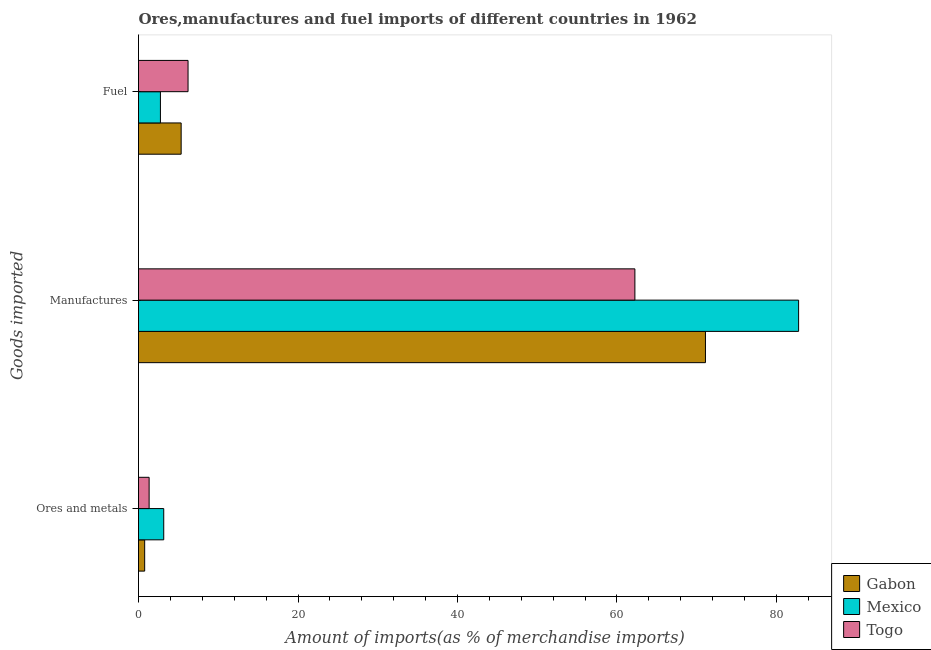How many different coloured bars are there?
Keep it short and to the point. 3. Are the number of bars per tick equal to the number of legend labels?
Your answer should be very brief. Yes. Are the number of bars on each tick of the Y-axis equal?
Keep it short and to the point. Yes. How many bars are there on the 2nd tick from the top?
Offer a very short reply. 3. How many bars are there on the 3rd tick from the bottom?
Give a very brief answer. 3. What is the label of the 2nd group of bars from the top?
Keep it short and to the point. Manufactures. What is the percentage of fuel imports in Mexico?
Your response must be concise. 2.75. Across all countries, what is the maximum percentage of manufactures imports?
Offer a terse response. 82.78. Across all countries, what is the minimum percentage of fuel imports?
Provide a succinct answer. 2.75. In which country was the percentage of ores and metals imports maximum?
Provide a short and direct response. Mexico. In which country was the percentage of ores and metals imports minimum?
Keep it short and to the point. Gabon. What is the total percentage of ores and metals imports in the graph?
Your response must be concise. 5.27. What is the difference between the percentage of fuel imports in Togo and that in Mexico?
Ensure brevity in your answer.  3.47. What is the difference between the percentage of ores and metals imports in Mexico and the percentage of manufactures imports in Togo?
Keep it short and to the point. -59.08. What is the average percentage of ores and metals imports per country?
Give a very brief answer. 1.76. What is the difference between the percentage of fuel imports and percentage of ores and metals imports in Togo?
Offer a terse response. 4.88. In how many countries, is the percentage of manufactures imports greater than 44 %?
Your response must be concise. 3. What is the ratio of the percentage of manufactures imports in Gabon to that in Mexico?
Provide a short and direct response. 0.86. Is the percentage of manufactures imports in Togo less than that in Gabon?
Keep it short and to the point. Yes. What is the difference between the highest and the second highest percentage of manufactures imports?
Your answer should be compact. 11.68. What is the difference between the highest and the lowest percentage of fuel imports?
Offer a very short reply. 3.47. What does the 1st bar from the top in Manufactures represents?
Keep it short and to the point. Togo. What does the 1st bar from the bottom in Manufactures represents?
Provide a succinct answer. Gabon. What is the difference between two consecutive major ticks on the X-axis?
Make the answer very short. 20. Does the graph contain any zero values?
Your answer should be very brief. No. Does the graph contain grids?
Provide a short and direct response. No. Where does the legend appear in the graph?
Provide a short and direct response. Bottom right. How are the legend labels stacked?
Ensure brevity in your answer.  Vertical. What is the title of the graph?
Keep it short and to the point. Ores,manufactures and fuel imports of different countries in 1962. What is the label or title of the X-axis?
Your response must be concise. Amount of imports(as % of merchandise imports). What is the label or title of the Y-axis?
Offer a very short reply. Goods imported. What is the Amount of imports(as % of merchandise imports) of Gabon in Ores and metals?
Offer a very short reply. 0.77. What is the Amount of imports(as % of merchandise imports) in Mexico in Ores and metals?
Your answer should be very brief. 3.16. What is the Amount of imports(as % of merchandise imports) in Togo in Ores and metals?
Your answer should be compact. 1.33. What is the Amount of imports(as % of merchandise imports) in Gabon in Manufactures?
Ensure brevity in your answer.  71.1. What is the Amount of imports(as % of merchandise imports) in Mexico in Manufactures?
Provide a short and direct response. 82.78. What is the Amount of imports(as % of merchandise imports) of Togo in Manufactures?
Keep it short and to the point. 62.25. What is the Amount of imports(as % of merchandise imports) of Gabon in Fuel?
Provide a short and direct response. 5.35. What is the Amount of imports(as % of merchandise imports) of Mexico in Fuel?
Provide a succinct answer. 2.75. What is the Amount of imports(as % of merchandise imports) of Togo in Fuel?
Give a very brief answer. 6.21. Across all Goods imported, what is the maximum Amount of imports(as % of merchandise imports) in Gabon?
Keep it short and to the point. 71.1. Across all Goods imported, what is the maximum Amount of imports(as % of merchandise imports) of Mexico?
Keep it short and to the point. 82.78. Across all Goods imported, what is the maximum Amount of imports(as % of merchandise imports) in Togo?
Your answer should be compact. 62.25. Across all Goods imported, what is the minimum Amount of imports(as % of merchandise imports) in Gabon?
Make the answer very short. 0.77. Across all Goods imported, what is the minimum Amount of imports(as % of merchandise imports) of Mexico?
Offer a terse response. 2.75. Across all Goods imported, what is the minimum Amount of imports(as % of merchandise imports) of Togo?
Your answer should be very brief. 1.33. What is the total Amount of imports(as % of merchandise imports) in Gabon in the graph?
Offer a very short reply. 77.22. What is the total Amount of imports(as % of merchandise imports) in Mexico in the graph?
Ensure brevity in your answer.  88.69. What is the total Amount of imports(as % of merchandise imports) of Togo in the graph?
Keep it short and to the point. 69.79. What is the difference between the Amount of imports(as % of merchandise imports) in Gabon in Ores and metals and that in Manufactures?
Provide a succinct answer. -70.32. What is the difference between the Amount of imports(as % of merchandise imports) of Mexico in Ores and metals and that in Manufactures?
Provide a short and direct response. -79.61. What is the difference between the Amount of imports(as % of merchandise imports) of Togo in Ores and metals and that in Manufactures?
Your answer should be compact. -60.92. What is the difference between the Amount of imports(as % of merchandise imports) of Gabon in Ores and metals and that in Fuel?
Give a very brief answer. -4.58. What is the difference between the Amount of imports(as % of merchandise imports) of Mexico in Ores and metals and that in Fuel?
Keep it short and to the point. 0.42. What is the difference between the Amount of imports(as % of merchandise imports) in Togo in Ores and metals and that in Fuel?
Ensure brevity in your answer.  -4.88. What is the difference between the Amount of imports(as % of merchandise imports) in Gabon in Manufactures and that in Fuel?
Offer a very short reply. 65.75. What is the difference between the Amount of imports(as % of merchandise imports) in Mexico in Manufactures and that in Fuel?
Your answer should be compact. 80.03. What is the difference between the Amount of imports(as % of merchandise imports) in Togo in Manufactures and that in Fuel?
Your response must be concise. 56.03. What is the difference between the Amount of imports(as % of merchandise imports) in Gabon in Ores and metals and the Amount of imports(as % of merchandise imports) in Mexico in Manufactures?
Your response must be concise. -82.01. What is the difference between the Amount of imports(as % of merchandise imports) in Gabon in Ores and metals and the Amount of imports(as % of merchandise imports) in Togo in Manufactures?
Provide a short and direct response. -61.48. What is the difference between the Amount of imports(as % of merchandise imports) in Mexico in Ores and metals and the Amount of imports(as % of merchandise imports) in Togo in Manufactures?
Provide a short and direct response. -59.08. What is the difference between the Amount of imports(as % of merchandise imports) in Gabon in Ores and metals and the Amount of imports(as % of merchandise imports) in Mexico in Fuel?
Your answer should be compact. -1.97. What is the difference between the Amount of imports(as % of merchandise imports) of Gabon in Ores and metals and the Amount of imports(as % of merchandise imports) of Togo in Fuel?
Offer a terse response. -5.44. What is the difference between the Amount of imports(as % of merchandise imports) in Mexico in Ores and metals and the Amount of imports(as % of merchandise imports) in Togo in Fuel?
Your answer should be very brief. -3.05. What is the difference between the Amount of imports(as % of merchandise imports) of Gabon in Manufactures and the Amount of imports(as % of merchandise imports) of Mexico in Fuel?
Your answer should be very brief. 68.35. What is the difference between the Amount of imports(as % of merchandise imports) of Gabon in Manufactures and the Amount of imports(as % of merchandise imports) of Togo in Fuel?
Give a very brief answer. 64.88. What is the difference between the Amount of imports(as % of merchandise imports) of Mexico in Manufactures and the Amount of imports(as % of merchandise imports) of Togo in Fuel?
Make the answer very short. 76.56. What is the average Amount of imports(as % of merchandise imports) of Gabon per Goods imported?
Give a very brief answer. 25.74. What is the average Amount of imports(as % of merchandise imports) in Mexico per Goods imported?
Offer a terse response. 29.56. What is the average Amount of imports(as % of merchandise imports) in Togo per Goods imported?
Ensure brevity in your answer.  23.26. What is the difference between the Amount of imports(as % of merchandise imports) in Gabon and Amount of imports(as % of merchandise imports) in Mexico in Ores and metals?
Make the answer very short. -2.39. What is the difference between the Amount of imports(as % of merchandise imports) of Gabon and Amount of imports(as % of merchandise imports) of Togo in Ores and metals?
Provide a succinct answer. -0.56. What is the difference between the Amount of imports(as % of merchandise imports) in Mexico and Amount of imports(as % of merchandise imports) in Togo in Ores and metals?
Offer a terse response. 1.83. What is the difference between the Amount of imports(as % of merchandise imports) of Gabon and Amount of imports(as % of merchandise imports) of Mexico in Manufactures?
Keep it short and to the point. -11.68. What is the difference between the Amount of imports(as % of merchandise imports) in Gabon and Amount of imports(as % of merchandise imports) in Togo in Manufactures?
Make the answer very short. 8.85. What is the difference between the Amount of imports(as % of merchandise imports) of Mexico and Amount of imports(as % of merchandise imports) of Togo in Manufactures?
Make the answer very short. 20.53. What is the difference between the Amount of imports(as % of merchandise imports) in Gabon and Amount of imports(as % of merchandise imports) in Mexico in Fuel?
Your answer should be compact. 2.6. What is the difference between the Amount of imports(as % of merchandise imports) of Gabon and Amount of imports(as % of merchandise imports) of Togo in Fuel?
Provide a short and direct response. -0.87. What is the difference between the Amount of imports(as % of merchandise imports) of Mexico and Amount of imports(as % of merchandise imports) of Togo in Fuel?
Make the answer very short. -3.47. What is the ratio of the Amount of imports(as % of merchandise imports) of Gabon in Ores and metals to that in Manufactures?
Offer a terse response. 0.01. What is the ratio of the Amount of imports(as % of merchandise imports) of Mexico in Ores and metals to that in Manufactures?
Your answer should be compact. 0.04. What is the ratio of the Amount of imports(as % of merchandise imports) of Togo in Ores and metals to that in Manufactures?
Offer a very short reply. 0.02. What is the ratio of the Amount of imports(as % of merchandise imports) in Gabon in Ores and metals to that in Fuel?
Make the answer very short. 0.14. What is the ratio of the Amount of imports(as % of merchandise imports) of Mexico in Ores and metals to that in Fuel?
Offer a very short reply. 1.15. What is the ratio of the Amount of imports(as % of merchandise imports) in Togo in Ores and metals to that in Fuel?
Ensure brevity in your answer.  0.21. What is the ratio of the Amount of imports(as % of merchandise imports) of Gabon in Manufactures to that in Fuel?
Keep it short and to the point. 13.29. What is the ratio of the Amount of imports(as % of merchandise imports) of Mexico in Manufactures to that in Fuel?
Your answer should be compact. 30.13. What is the ratio of the Amount of imports(as % of merchandise imports) in Togo in Manufactures to that in Fuel?
Provide a short and direct response. 10.02. What is the difference between the highest and the second highest Amount of imports(as % of merchandise imports) in Gabon?
Your answer should be compact. 65.75. What is the difference between the highest and the second highest Amount of imports(as % of merchandise imports) in Mexico?
Your response must be concise. 79.61. What is the difference between the highest and the second highest Amount of imports(as % of merchandise imports) of Togo?
Provide a succinct answer. 56.03. What is the difference between the highest and the lowest Amount of imports(as % of merchandise imports) in Gabon?
Provide a succinct answer. 70.32. What is the difference between the highest and the lowest Amount of imports(as % of merchandise imports) in Mexico?
Provide a succinct answer. 80.03. What is the difference between the highest and the lowest Amount of imports(as % of merchandise imports) in Togo?
Your response must be concise. 60.92. 